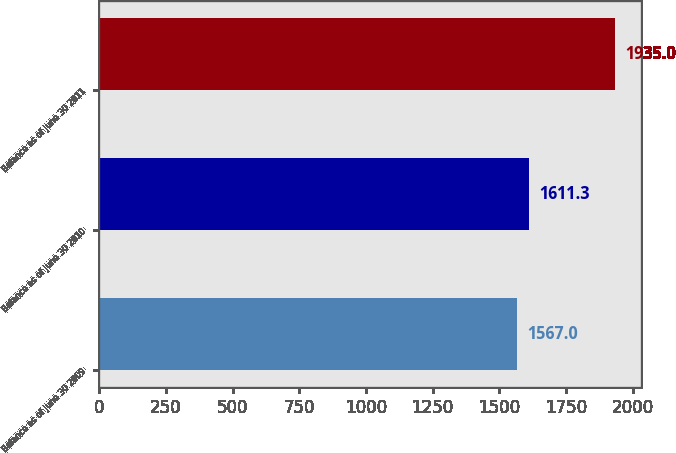Convert chart to OTSL. <chart><loc_0><loc_0><loc_500><loc_500><bar_chart><fcel>Balance as of June 30 2009<fcel>Balance as of June 30 2010<fcel>Balance as of June 30 2011<nl><fcel>1567<fcel>1611.3<fcel>1935<nl></chart> 